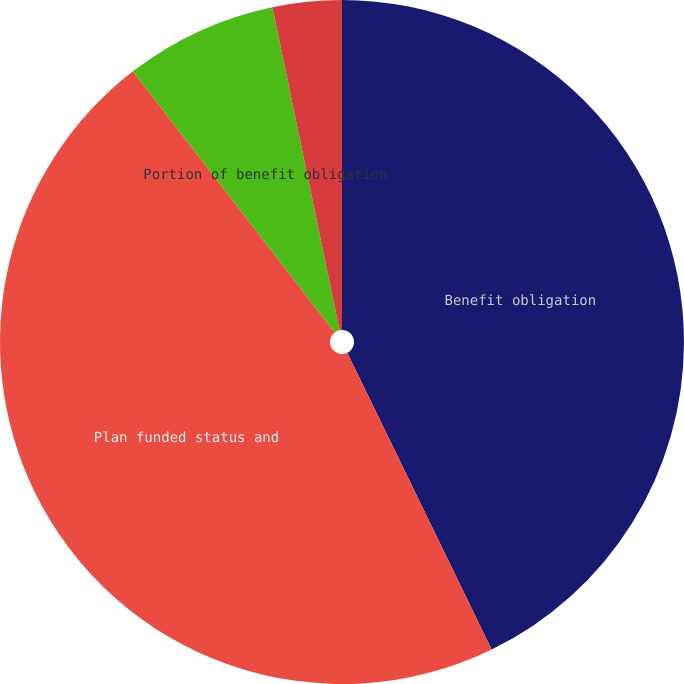Convert chart to OTSL. <chart><loc_0><loc_0><loc_500><loc_500><pie_chart><fcel>Benefit obligation<fcel>Plan funded status and<fcel>Portion of benefit obligation<fcel>Benefits expense<nl><fcel>42.79%<fcel>46.74%<fcel>7.21%<fcel>3.26%<nl></chart> 